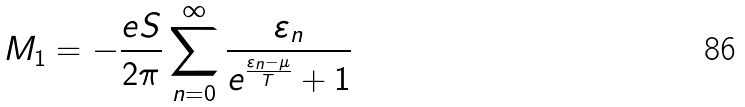Convert formula to latex. <formula><loc_0><loc_0><loc_500><loc_500>M _ { 1 } = - \frac { e S } { 2 \pi } \sum _ { n = 0 } ^ { \infty } \frac { \varepsilon _ { n } } { e ^ { \frac { \varepsilon _ { n } - \mu } { T } } + 1 }</formula> 